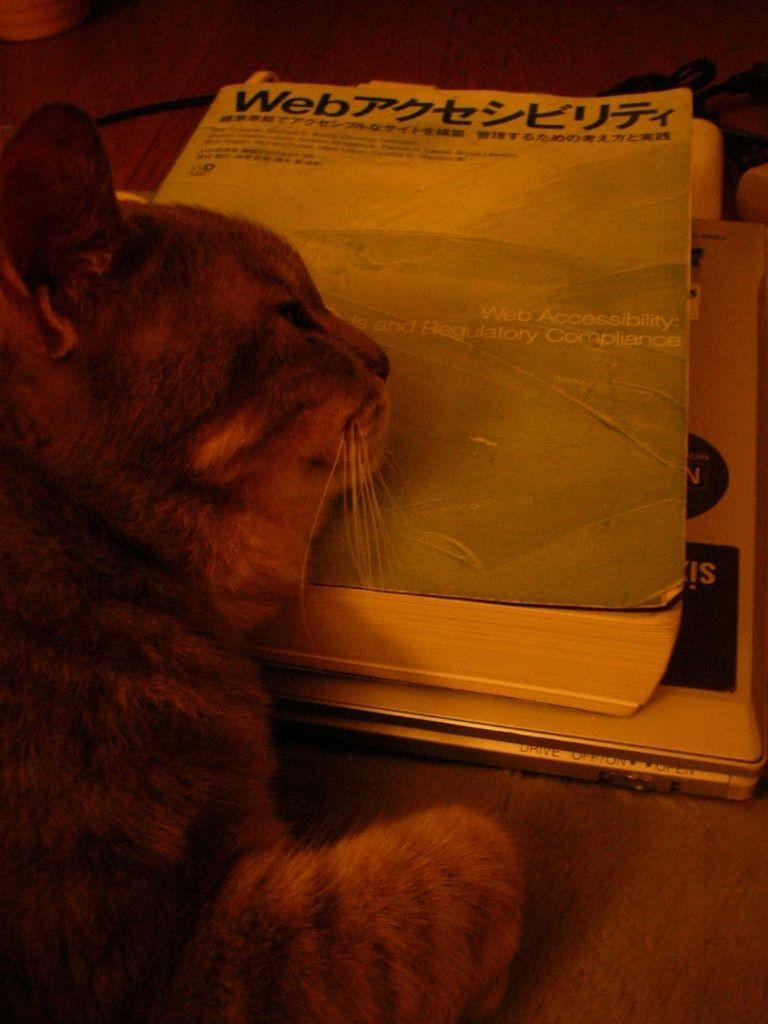What is the cat doing in the image? The cat is lying on a book. What can be seen on the book? Text is visible on the book. What is under the book? There are objects under the book. What is the wire attached to in the image? The wire is on a wooden surface. What else is present on the wooden surface? There is an unspecified object on the wooden surface. How many loaves of bread are visible in the image? There are no loaves of bread present in the image. Can you see any kittens playing with sand in the image? There are no kittens or sand present in the image. 